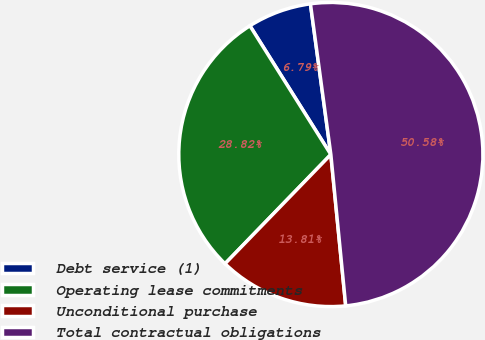Convert chart. <chart><loc_0><loc_0><loc_500><loc_500><pie_chart><fcel>Debt service (1)<fcel>Operating lease commitments<fcel>Unconditional purchase<fcel>Total contractual obligations<nl><fcel>6.79%<fcel>28.82%<fcel>13.81%<fcel>50.59%<nl></chart> 